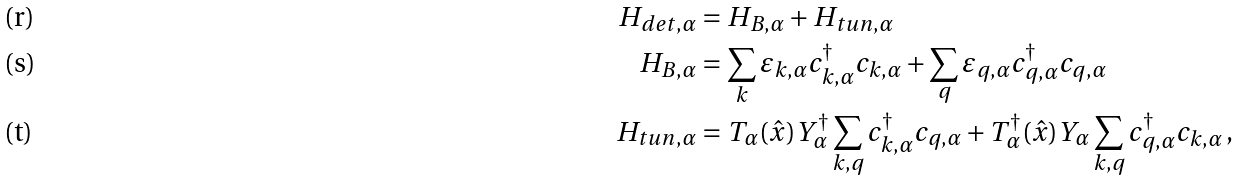Convert formula to latex. <formula><loc_0><loc_0><loc_500><loc_500>H _ { d e t , \alpha } & = H _ { B , \alpha } + H _ { t u n , \alpha } \\ H _ { B , \alpha } & = \sum _ { k } \varepsilon _ { k , \alpha } c ^ { \dagger } _ { k , \alpha } c _ { k , \alpha } + \sum _ { q } \varepsilon _ { q , \alpha } c ^ { \dagger } _ { q , \alpha } c _ { q , \alpha } \\ H _ { t u n , \alpha } & = T _ { \alpha } ( \hat { x } ) Y ^ { \dagger } _ { \alpha } \sum _ { k , q } c ^ { \dagger } _ { k , \alpha } c _ { q , \alpha } + T ^ { \dagger } _ { \alpha } ( \hat { x } ) Y _ { \alpha } \sum _ { k , q } c ^ { \dagger } _ { q , \alpha } c _ { k , \alpha } \, ,</formula> 